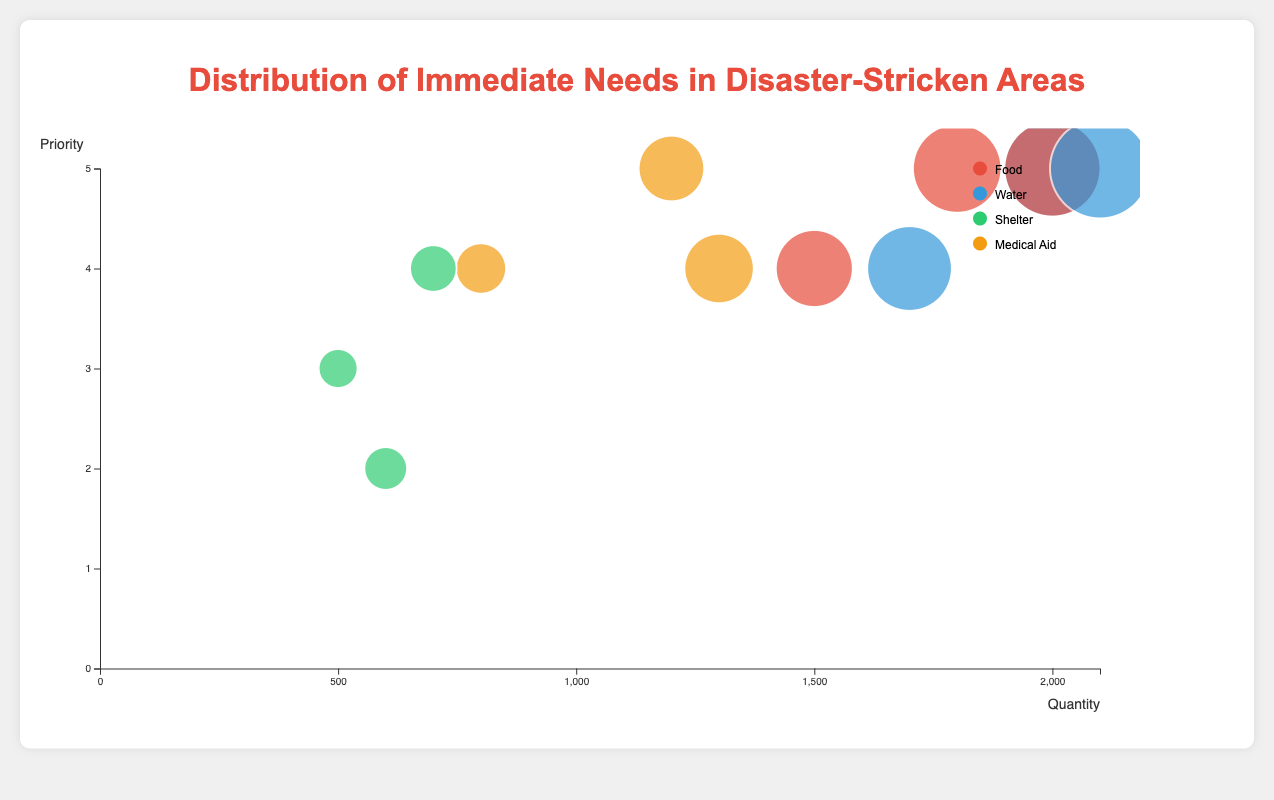how many regions are represented in the figure? the figure includes region a, region b, and region c. so there are three regions represented.
Answer: three which entity has the highest priority in region a? looking at region a, water has the highest priority of 5.
Answer: water what is the total quantity of food needed across all regions? summing up the quantities for food across all regions: 1500 (region a) + 1800 (region b) + 2000 (region c) = 5300.
Answer: 5300 which region has the highest quantity of water needed, and what is the quantity? region c has the highest quantity of water needed, with a total of 2100.
Answer: region c, 2100 what is the average priority for medical aid across all regions? summing the priorities for medical aid: 4 (region a) + 5 (region b) + 4 (region c) = 13. the average is 13 / 3 regions = 4.33.
Answer: 4.33 which entity in region b has the lowest priority? in region b, shelter has the lowest priority of 2.
Answer: shelter compare the quantity of shelter needed in region a to region c. which is higher, and by how much? region c needs 700 units of shelter, while region a needs 500. region c needs 200 more units of shelter than region a.
Answer: region c, 200 is there any entity with the same quantity needed across different regions? no, when comparing quantities, all entities have distinct quantities needed across different regions.
Answer: no which region has the highest overall priority for food? all regions (a, b, c) place a high priority on food, with region b and region c both having equal highest priority of 5
Answer: region b and c what's the ratio of the quantity of water needed between region b and region a? the quantity of water needed in region b is 1700, and in region a it is 2000. the ratio is 1700 / 2000 = 0.85.
Answer: 0.85 